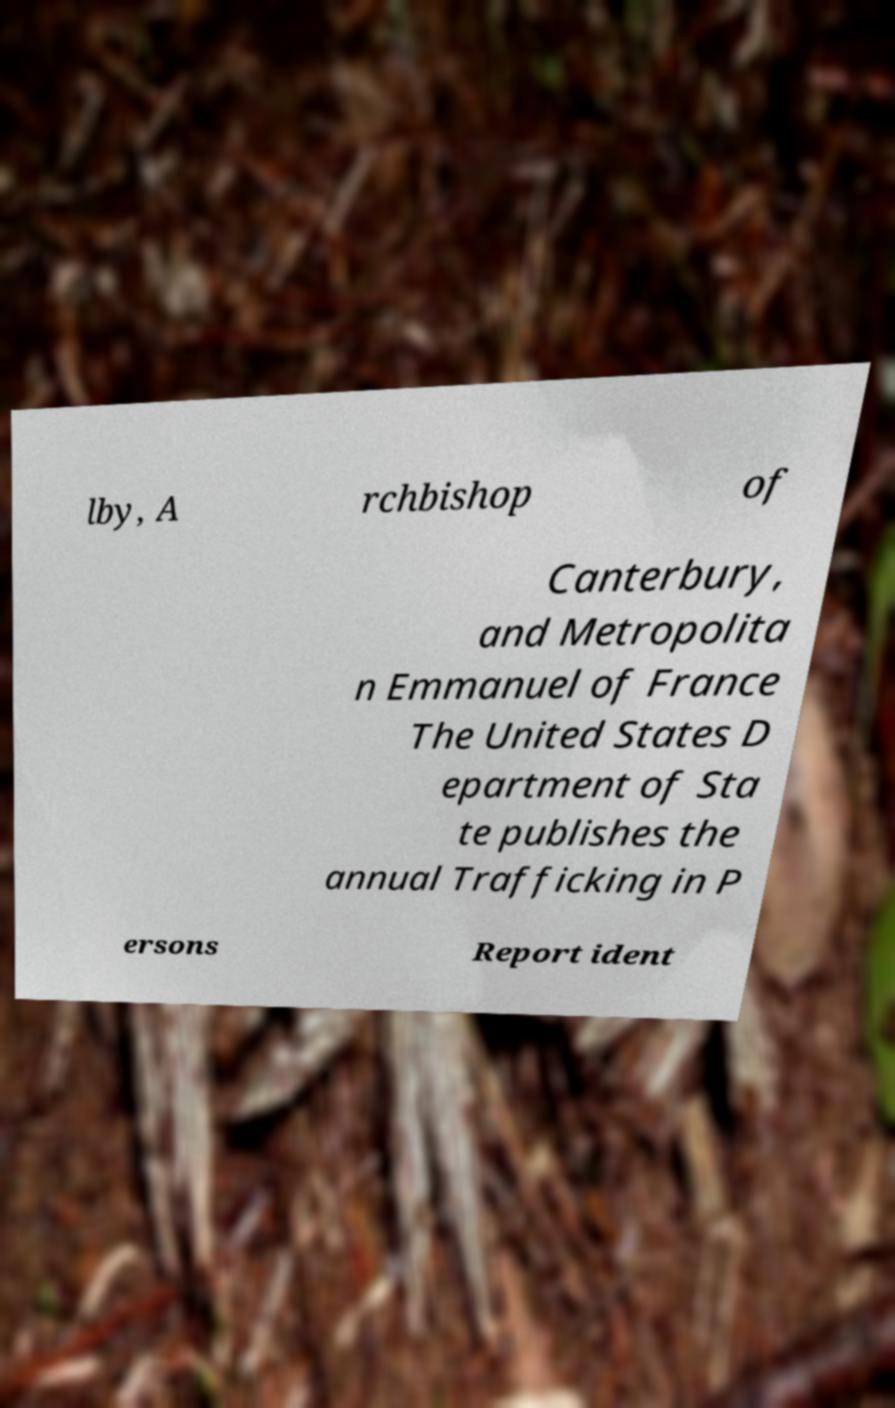Can you accurately transcribe the text from the provided image for me? lby, A rchbishop of Canterbury, and Metropolita n Emmanuel of France The United States D epartment of Sta te publishes the annual Trafficking in P ersons Report ident 